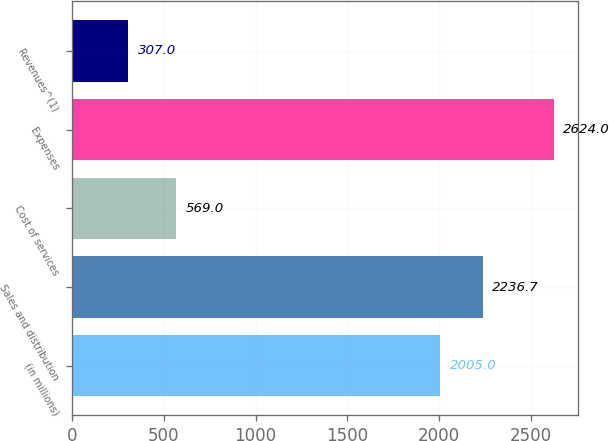Convert chart to OTSL. <chart><loc_0><loc_0><loc_500><loc_500><bar_chart><fcel>(in millions)<fcel>Sales and distribution<fcel>Cost of services<fcel>Expenses<fcel>Revenues^(1)<nl><fcel>2005<fcel>2236.7<fcel>569<fcel>2624<fcel>307<nl></chart> 